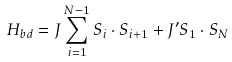<formula> <loc_0><loc_0><loc_500><loc_500>H _ { b d } = J \sum _ { i = 1 } ^ { N - 1 } { S } _ { i } \cdot { S } _ { i + 1 } + J ^ { \prime } { S _ { 1 } } \cdot { S } _ { N }</formula> 